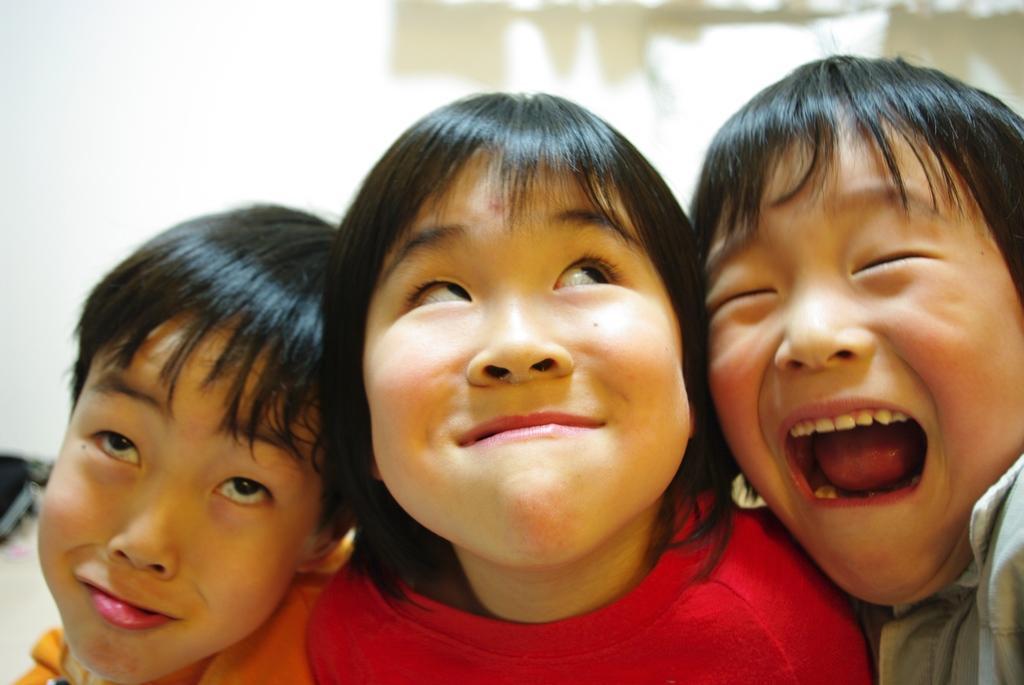Can you describe this image briefly? In this picture I can see a girl and couple of boys and I can see blurry background. 